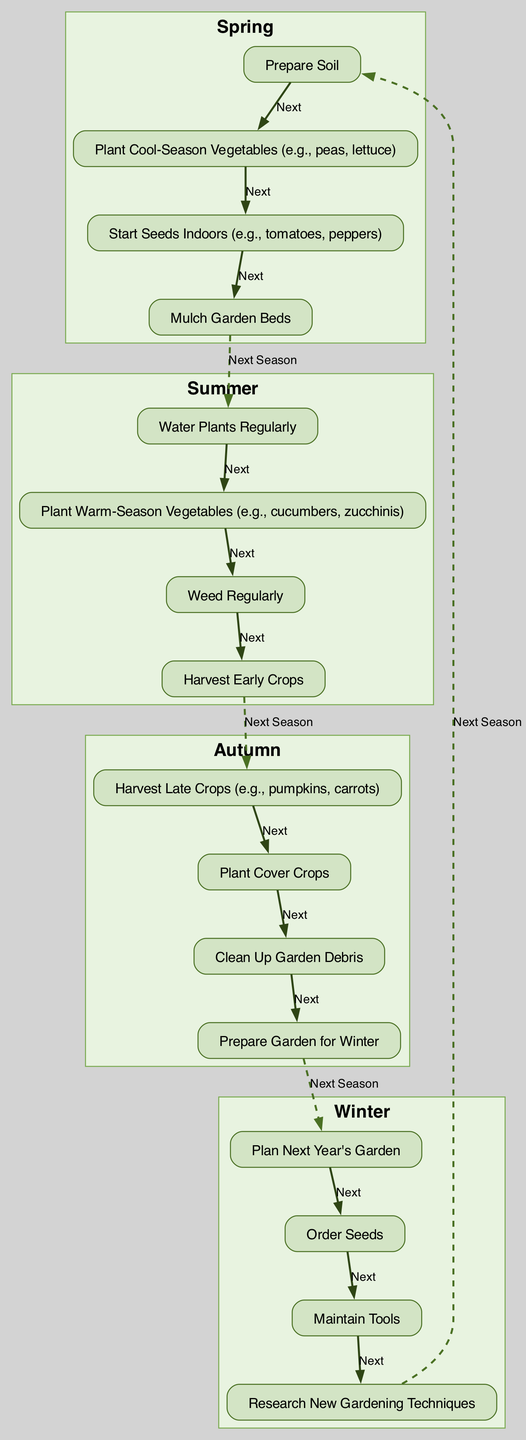What is the first activity in Spring? The first activity in Spring is "Prepare Soil". This can be found at the top of the Spring section in the diagram.
Answer: Prepare Soil How many activities are listed for Autumn? There are four activities listed for Autumn. By counting the items under the Autumn section in the diagram, we find a total of four distinct activities.
Answer: 4 Which season includes the activity "Water Plants Regularly"? The activity "Water Plants Regularly" is included in the Summer section. We can find this activity by looking at the listed activities in the Summer cluster of the diagram.
Answer: Summer What connects the last activity in each season to the first activity in the next season? The last activity in each season connects to the first activity in the next season with a dashed edge labeled "Next Season". This is indicated in the flowchart connecting the seasons.
Answer: Dashed edge What is the second activity in Winter? The second activity in Winter is "Order Seeds". The activities within Winter are listed sequentially, and the second item in that sequence clearly states "Order Seeds".
Answer: Order Seeds What activity follows "Plant Cool-Season Vegetables"? The activity that follows "Plant Cool-Season Vegetables" is "Start Seeds Indoors". This can be determined by looking at the order of activities within the Spring section.
Answer: Start Seeds Indoors Which two activities are connected under the Summer section? The two activities connected under the Summer section are "Water Plants Regularly" and "Plant Warm-Season Vegetables". Each Summer activity flows into the next, showing their connections.
Answer: Water Plants Regularly, Plant Warm-Season Vegetables What is the last activity listed in Autumn? The last activity listed in Autumn is "Prepare Garden for Winter". By examining the Autumn section, we can see that this is the final activity in the list.
Answer: Prepare Garden for Winter 